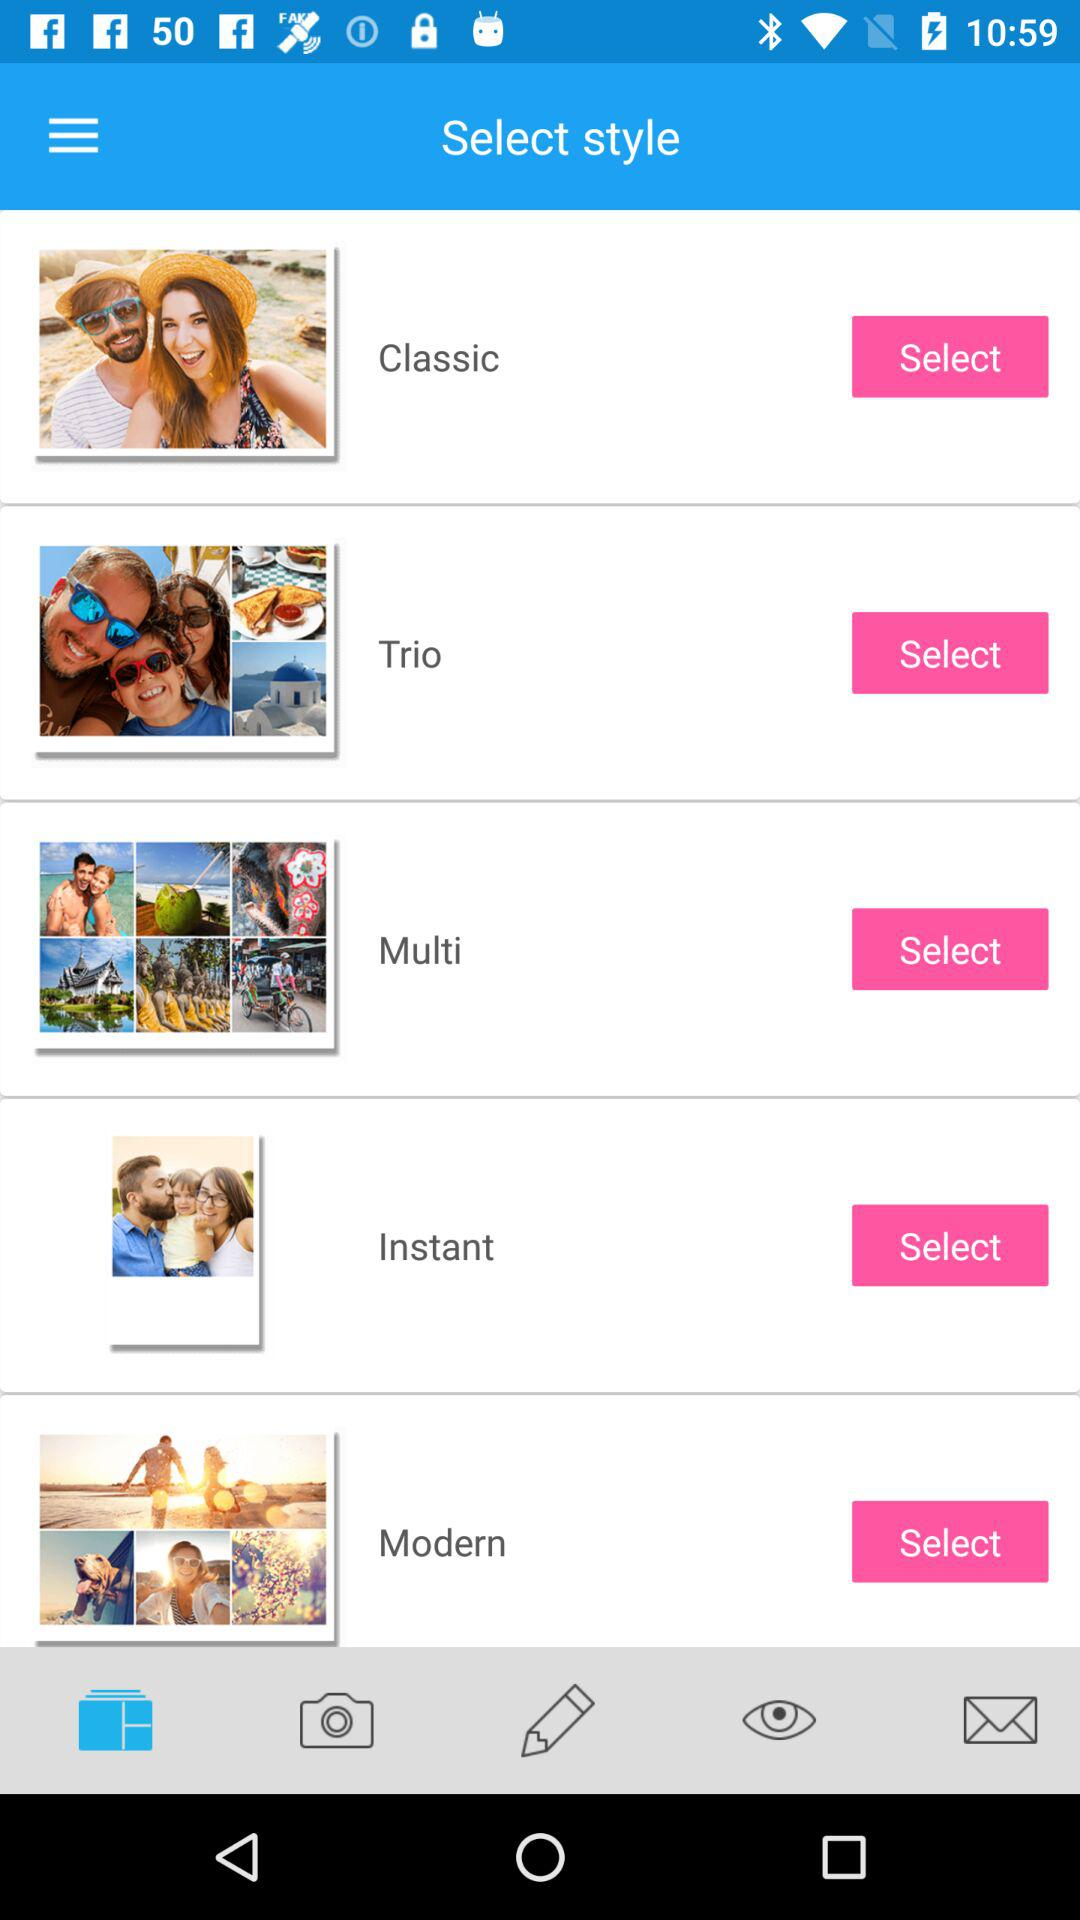What are the different styles available? The different styles available are "Classic", "Trio", "Multi", "Instant", and "Modern". 